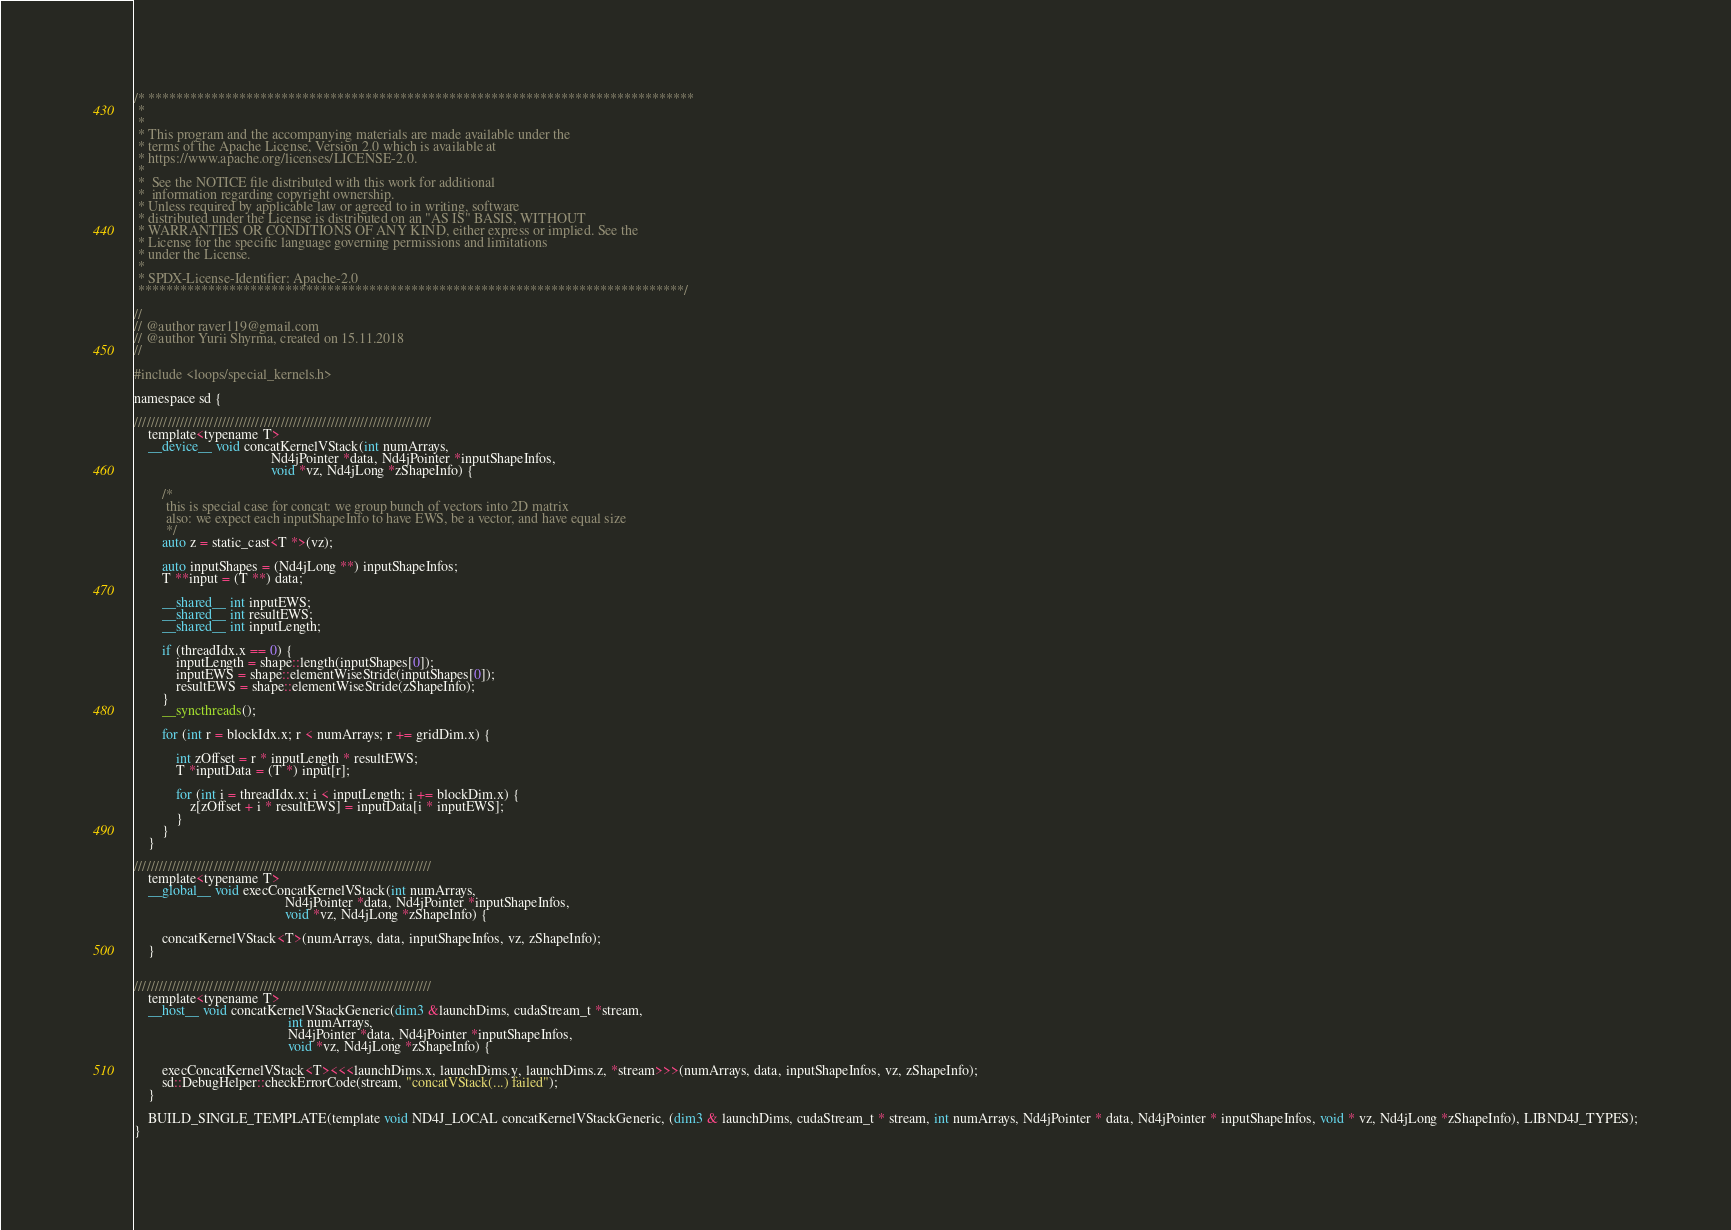<code> <loc_0><loc_0><loc_500><loc_500><_Cuda_>/* ******************************************************************************
 *
 *
 * This program and the accompanying materials are made available under the
 * terms of the Apache License, Version 2.0 which is available at
 * https://www.apache.org/licenses/LICENSE-2.0.
 *
 *  See the NOTICE file distributed with this work for additional
 *  information regarding copyright ownership.
 * Unless required by applicable law or agreed to in writing, software
 * distributed under the License is distributed on an "AS IS" BASIS, WITHOUT
 * WARRANTIES OR CONDITIONS OF ANY KIND, either express or implied. See the
 * License for the specific language governing permissions and limitations
 * under the License.
 *
 * SPDX-License-Identifier: Apache-2.0
 ******************************************************************************/

//
// @author raver119@gmail.com
// @author Yurii Shyrma, created on 15.11.2018
//

#include <loops/special_kernels.h>

namespace sd {

///////////////////////////////////////////////////////////////////////
    template<typename T>
    __device__ void concatKernelVStack(int numArrays,
                                       Nd4jPointer *data, Nd4jPointer *inputShapeInfos,
                                       void *vz, Nd4jLong *zShapeInfo) {

        /*
         this is special case for concat: we group bunch of vectors into 2D matrix
         also: we expect each inputShapeInfo to have EWS, be a vector, and have equal size
         */
        auto z = static_cast<T *>(vz);

        auto inputShapes = (Nd4jLong **) inputShapeInfos;
        T **input = (T **) data;

        __shared__ int inputEWS;
        __shared__ int resultEWS;
        __shared__ int inputLength;

        if (threadIdx.x == 0) {
            inputLength = shape::length(inputShapes[0]);
            inputEWS = shape::elementWiseStride(inputShapes[0]);
            resultEWS = shape::elementWiseStride(zShapeInfo);
        }
        __syncthreads();

        for (int r = blockIdx.x; r < numArrays; r += gridDim.x) {

            int zOffset = r * inputLength * resultEWS;
            T *inputData = (T *) input[r];

            for (int i = threadIdx.x; i < inputLength; i += blockDim.x) {
                z[zOffset + i * resultEWS] = inputData[i * inputEWS];
            }
        }
    }

///////////////////////////////////////////////////////////////////////
    template<typename T>
    __global__ void execConcatKernelVStack(int numArrays,
                                           Nd4jPointer *data, Nd4jPointer *inputShapeInfos,
                                           void *vz, Nd4jLong *zShapeInfo) {

        concatKernelVStack<T>(numArrays, data, inputShapeInfos, vz, zShapeInfo);
    }


///////////////////////////////////////////////////////////////////////
    template<typename T>
    __host__ void concatKernelVStackGeneric(dim3 &launchDims, cudaStream_t *stream,
                                            int numArrays,
                                            Nd4jPointer *data, Nd4jPointer *inputShapeInfos,
                                            void *vz, Nd4jLong *zShapeInfo) {

        execConcatKernelVStack<T><<<launchDims.x, launchDims.y, launchDims.z, *stream>>>(numArrays, data, inputShapeInfos, vz, zShapeInfo);
        sd::DebugHelper::checkErrorCode(stream, "concatVStack(...) failed");
    }

    BUILD_SINGLE_TEMPLATE(template void ND4J_LOCAL concatKernelVStackGeneric, (dim3 & launchDims, cudaStream_t * stream, int numArrays, Nd4jPointer * data, Nd4jPointer * inputShapeInfos, void * vz, Nd4jLong *zShapeInfo), LIBND4J_TYPES);
}</code> 